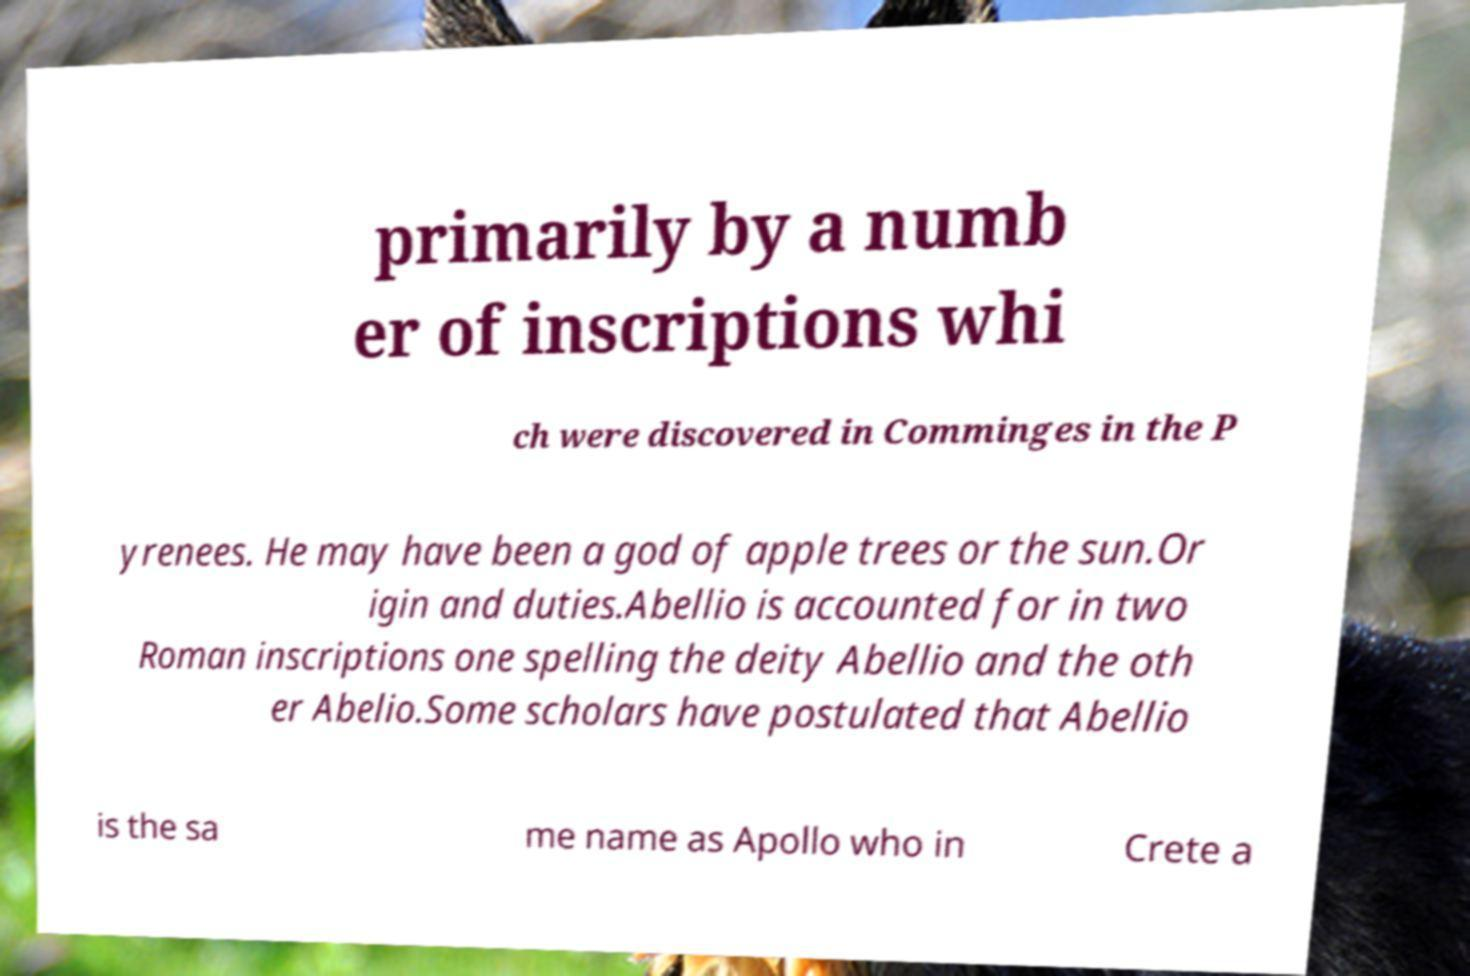Can you accurately transcribe the text from the provided image for me? primarily by a numb er of inscriptions whi ch were discovered in Comminges in the P yrenees. He may have been a god of apple trees or the sun.Or igin and duties.Abellio is accounted for in two Roman inscriptions one spelling the deity Abellio and the oth er Abelio.Some scholars have postulated that Abellio is the sa me name as Apollo who in Crete a 